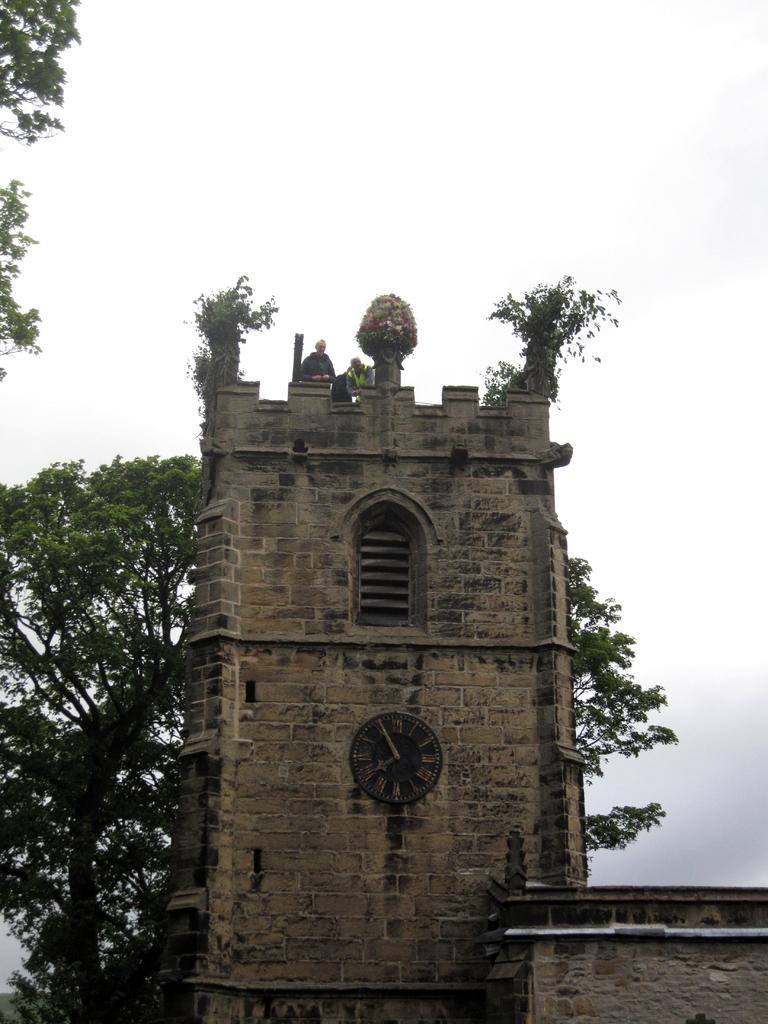Could you give a brief overview of what you see in this image? In this image I can see a building which is cream, brown and black in color. I can see a clock to the building and few trees which are green and black in color. In the background I can see the sky. 